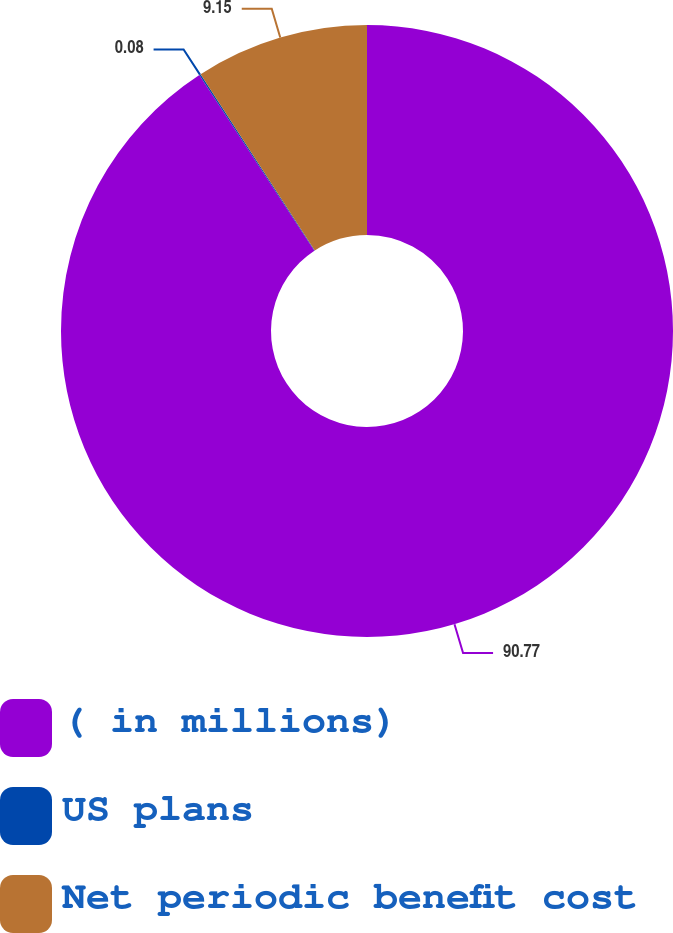Convert chart. <chart><loc_0><loc_0><loc_500><loc_500><pie_chart><fcel>( in millions)<fcel>US plans<fcel>Net periodic benefit cost<nl><fcel>90.77%<fcel>0.08%<fcel>9.15%<nl></chart> 